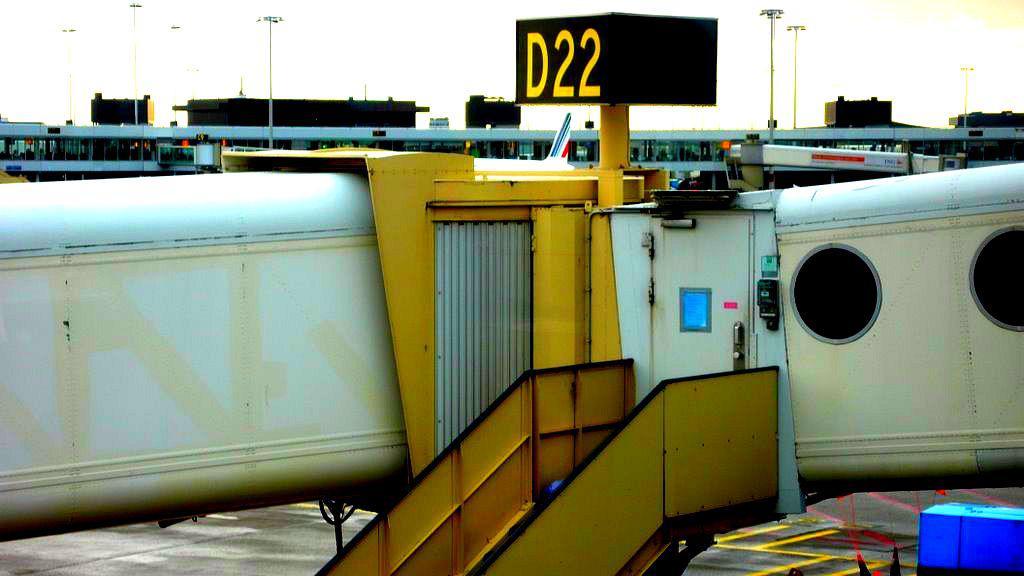What is the sign with yellow text displaying?
Offer a terse response. D22. 